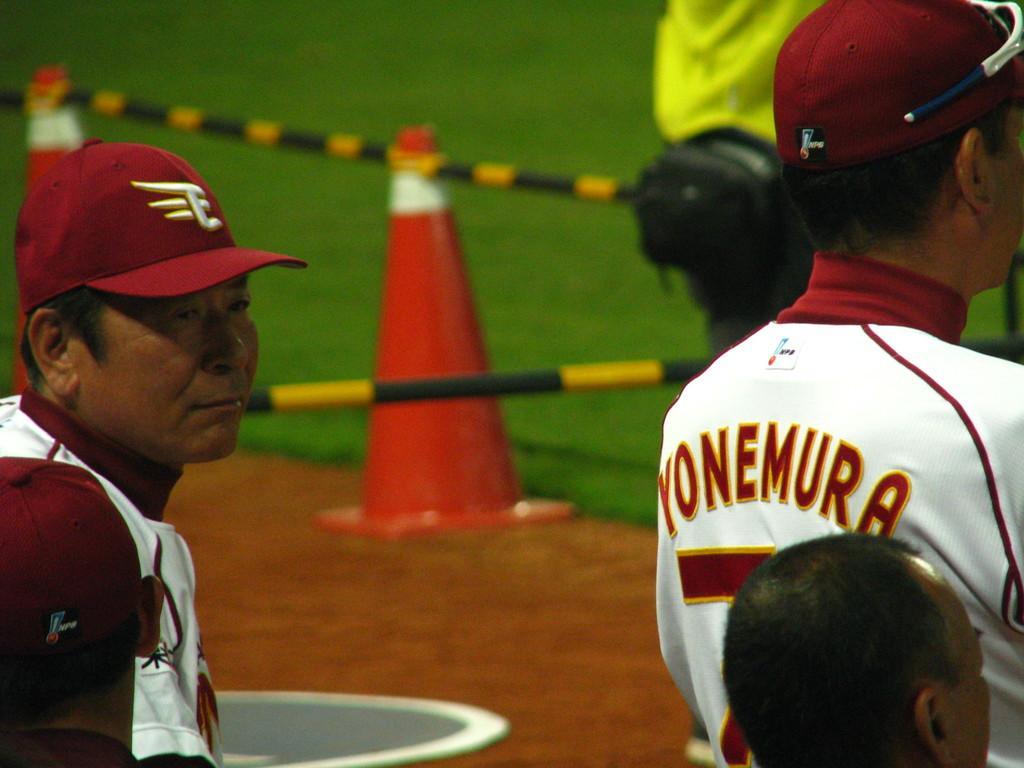Describe this image in one or two sentences. In this picture we can see few people, two persons in the front wore caps, in the background there is grass, we can see two rods and a traffic cone in the middle. 